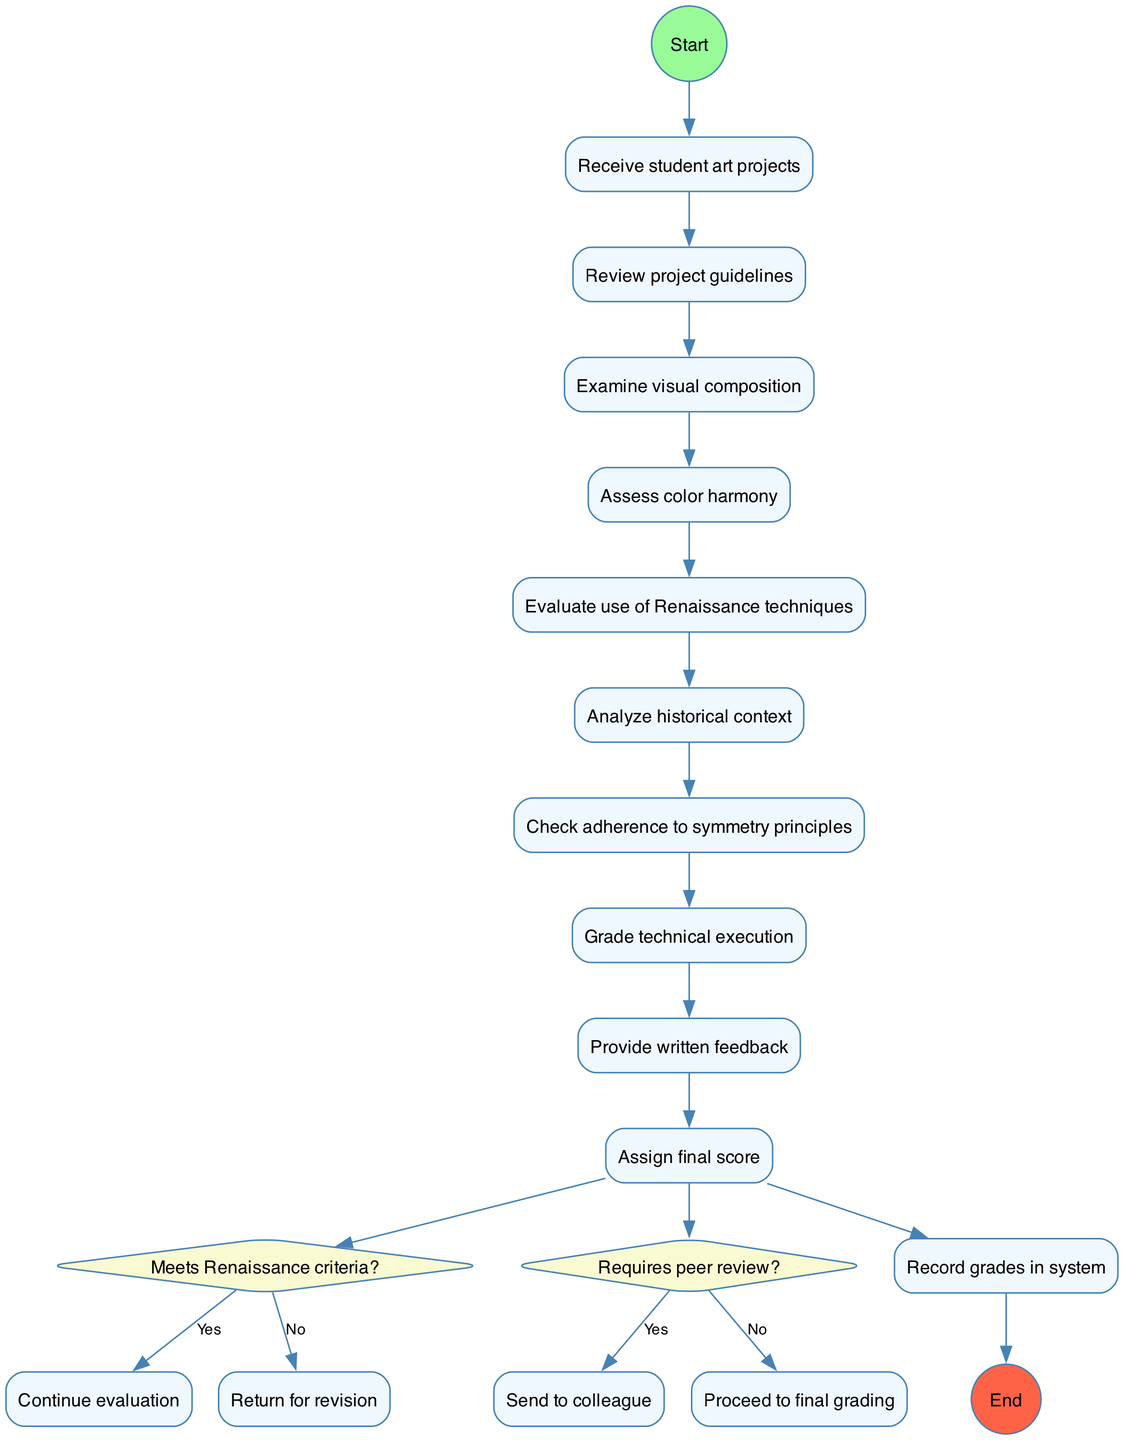What is the start node of the diagram? The start node is labeled as "Receive student art projects," which is the first activity in the process. This can be observed directly from the start point of the flow in the diagram.
Answer: Receive student art projects How many decision nodes are present in the diagram? There are two decision nodes in the diagram, each corresponding to a different question regarding the evaluation process. This can be counted directly from the number of diamond-shaped nodes labeled as questions.
Answer: 2 What activity follows "Examine visual composition"? The activity that directly follows "Examine visual composition" is "Assess color harmony." This is determined by tracing the flow from the "Examine visual composition" node to the next activity node in the sequence.
Answer: Assess color harmony What happens if the artwork does not meet Renaissance criteria? If the artwork does not meet Renaissance criteria, the process states "Return for revision." This is indicated in the decision node leading to the ‘no’ option.
Answer: Return for revision What is the last activity before grading technical execution? The last activity before grading technical execution is "Check adherence to symmetry principles." By following the flow of activities, we can see this sequence leading up to the grading stage.
Answer: Check adherence to symmetry principles If the decision on Renaissance criteria is 'Yes', what is the next step? If the answer to the Renaissance criteria question is 'Yes', the flow continues with the next steps of evaluation, meaning "Continue evaluation." This follows from the option indicated under the decision node.
Answer: Continue evaluation What is the final recorded action in the diagram? The final action recorded in the diagram is "Record grades in system." After all evaluations and grading, this step concludes the process as represented by the end node.
Answer: Record grades in system 